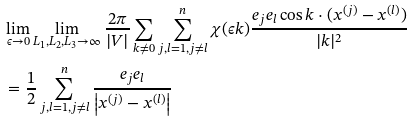<formula> <loc_0><loc_0><loc_500><loc_500>& \lim _ { \epsilon \rightarrow 0 } \lim _ { L _ { 1 } , L _ { 2 } , L _ { 3 } \rightarrow \infty } \frac { 2 \pi } { | V | } \sum _ { k \not = 0 } \sum _ { j , l = 1 , j \not = l } ^ { n } \chi ( \epsilon k ) \frac { e _ { j } e _ { l } \cos k \cdot ( x ^ { ( j ) } - x ^ { ( l ) } ) } { | k | ^ { 2 } } \\ & = \frac { 1 } { 2 } \sum _ { j , l = 1 , j \not = l } ^ { n } \frac { e _ { j } e _ { l } } { \left | x ^ { ( j ) } - x ^ { ( l ) } \right | }</formula> 